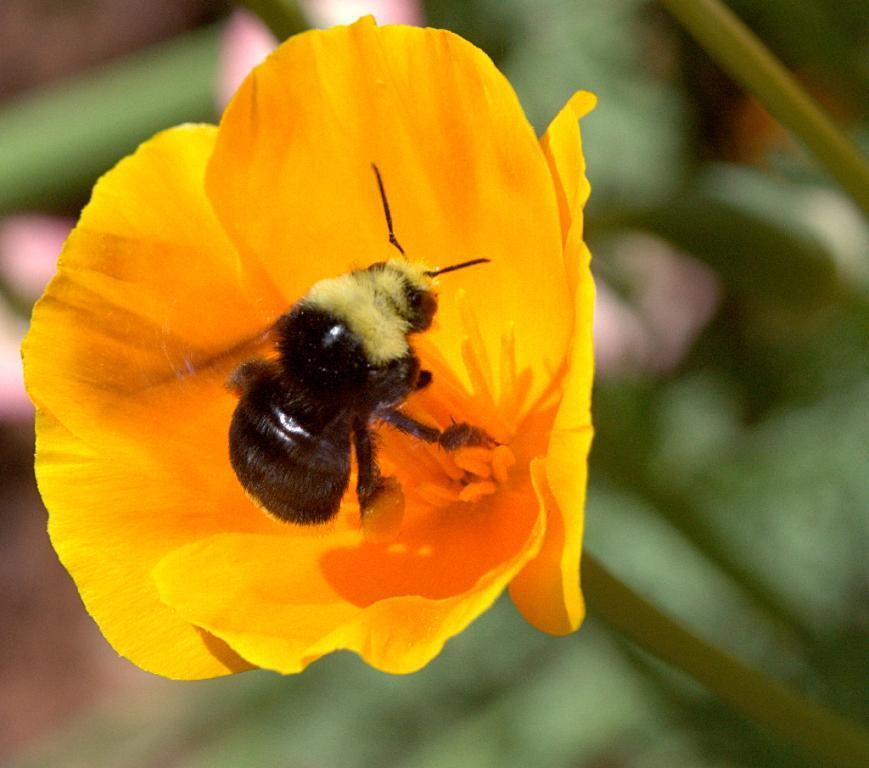What is present in the image? There is a bug in the image. Where is the bug located? The bug is on a flower. What is the position of the flower in the image? The flower is in the center of the image. What form of regret does the flower express in the image? The flower does not express regret in the image, as it is a non-living object and cannot experience emotions like regret. 